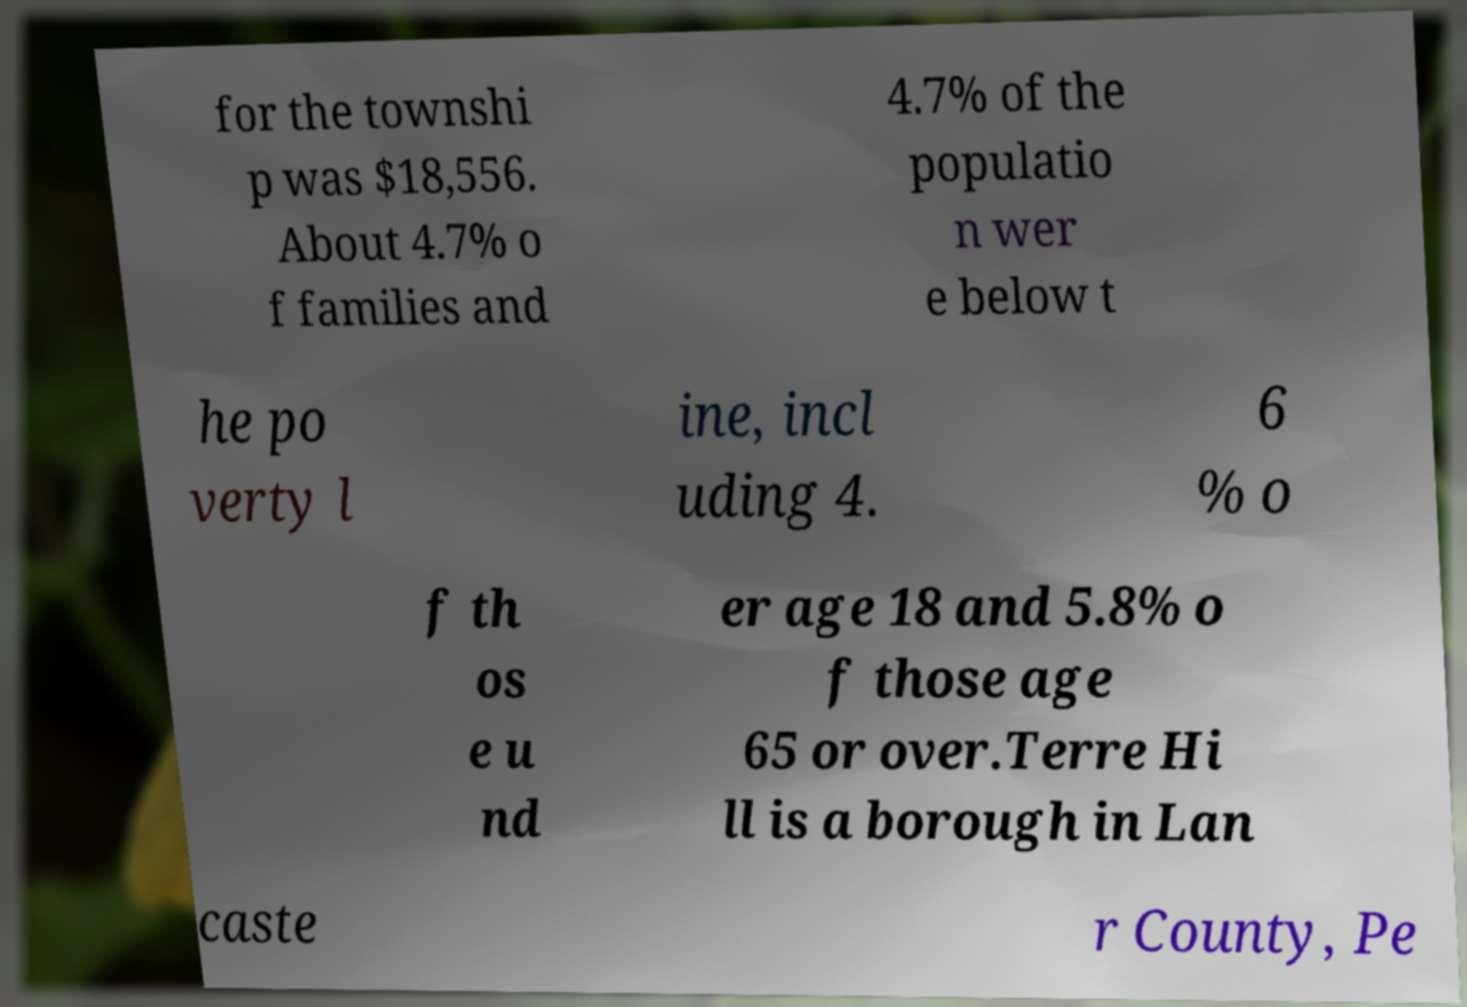For documentation purposes, I need the text within this image transcribed. Could you provide that? for the townshi p was $18,556. About 4.7% o f families and 4.7% of the populatio n wer e below t he po verty l ine, incl uding 4. 6 % o f th os e u nd er age 18 and 5.8% o f those age 65 or over.Terre Hi ll is a borough in Lan caste r County, Pe 